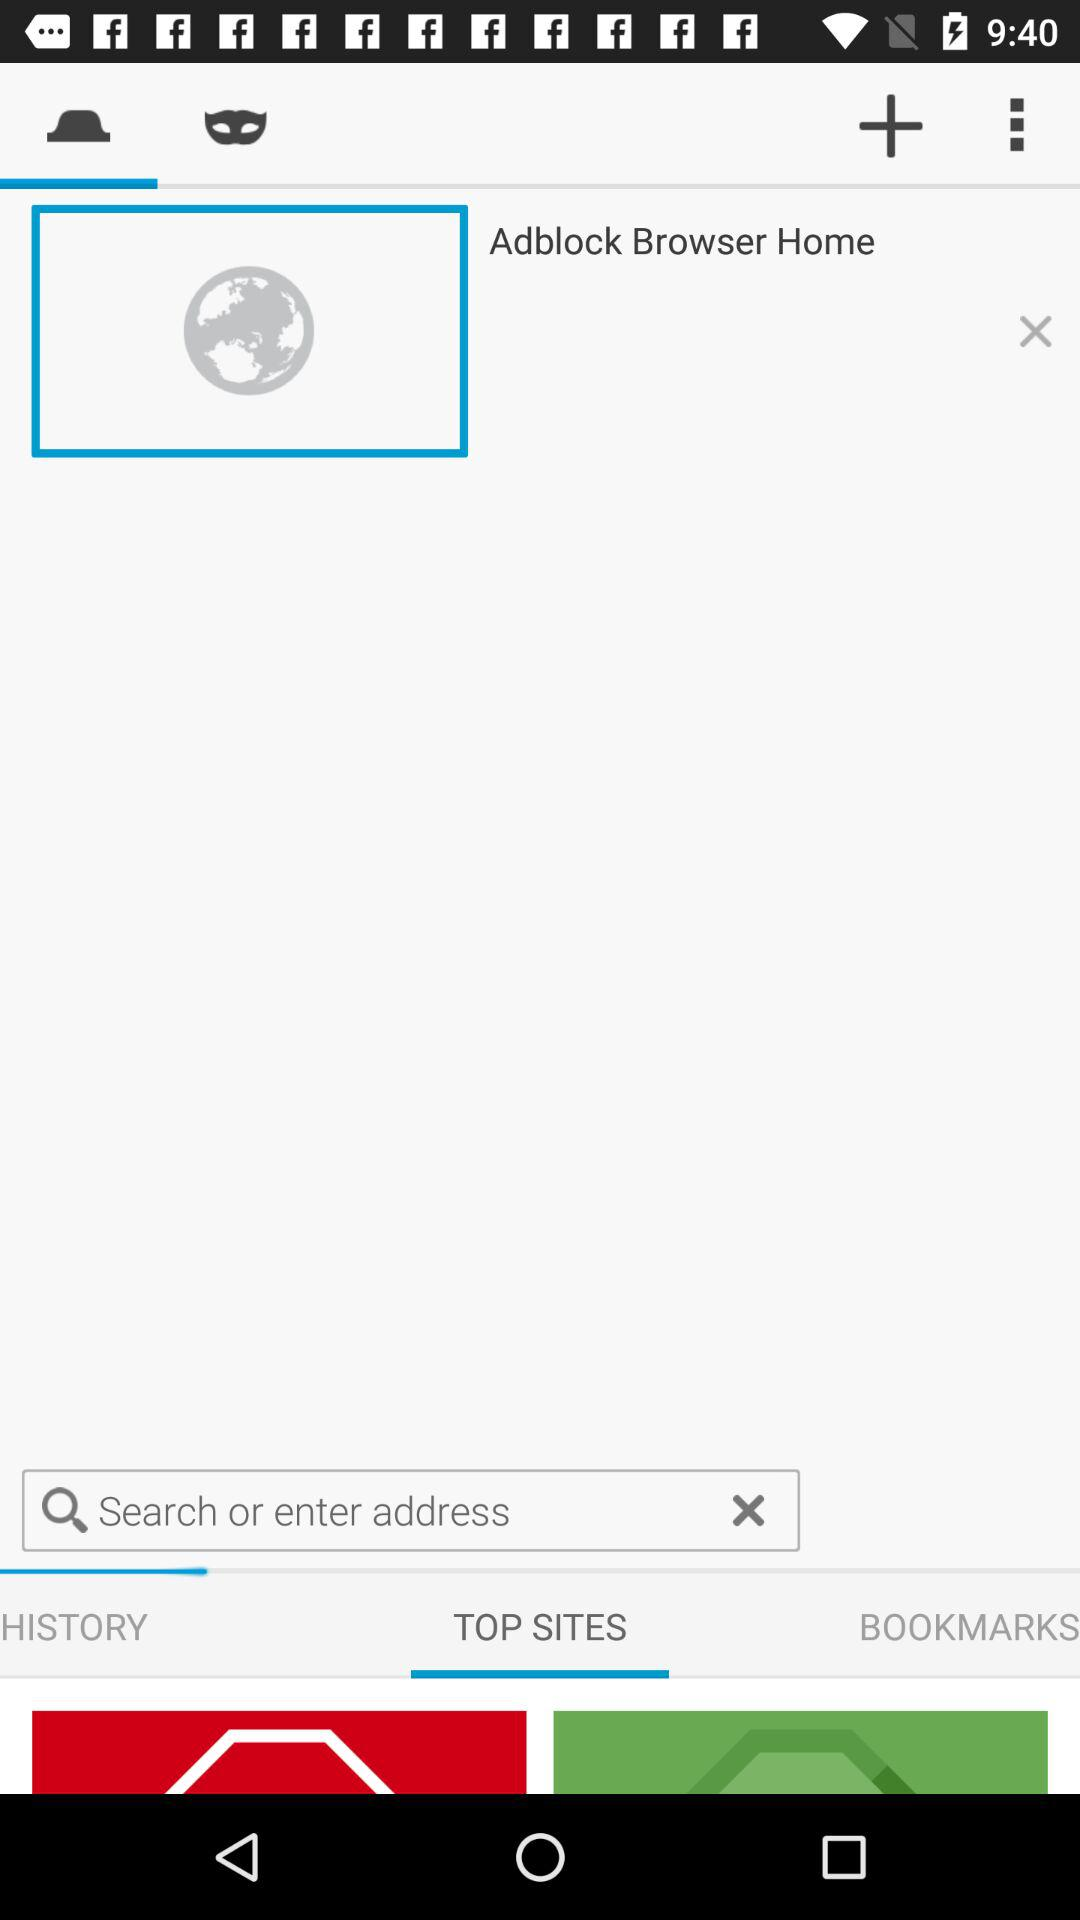Which tab is currently selected? TOP SITES tab is selected. 